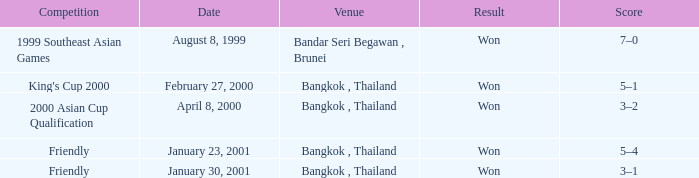Could you help me parse every detail presented in this table? {'header': ['Competition', 'Date', 'Venue', 'Result', 'Score'], 'rows': [['1999 Southeast Asian Games', 'August 8, 1999', 'Bandar Seri Begawan , Brunei', 'Won', '7–0'], ["King's Cup 2000", 'February 27, 2000', 'Bangkok , Thailand', 'Won', '5–1'], ['2000 Asian Cup Qualification', 'April 8, 2000', 'Bangkok , Thailand', 'Won', '3–2'], ['Friendly', 'January 23, 2001', 'Bangkok , Thailand', 'Won', '5–4'], ['Friendly', 'January 30, 2001', 'Bangkok , Thailand', 'Won', '3–1']]} On what date was the game that had a score of 7–0? August 8, 1999. 